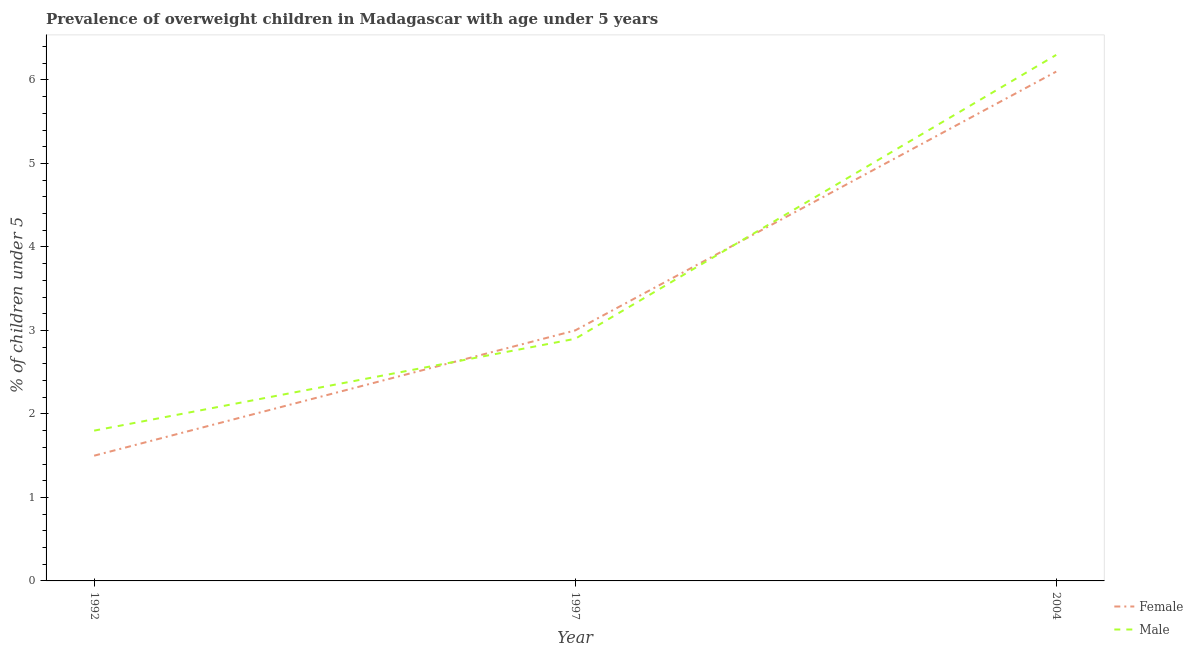How many different coloured lines are there?
Your answer should be very brief. 2. What is the percentage of obese female children in 2004?
Provide a succinct answer. 6.1. Across all years, what is the maximum percentage of obese female children?
Offer a very short reply. 6.1. In which year was the percentage of obese male children minimum?
Provide a succinct answer. 1992. What is the total percentage of obese male children in the graph?
Ensure brevity in your answer.  11. What is the difference between the percentage of obese male children in 1997 and that in 2004?
Your response must be concise. -3.4. What is the difference between the percentage of obese male children in 2004 and the percentage of obese female children in 1997?
Make the answer very short. 3.3. What is the average percentage of obese female children per year?
Your answer should be compact. 3.53. In the year 1997, what is the difference between the percentage of obese female children and percentage of obese male children?
Provide a succinct answer. 0.1. In how many years, is the percentage of obese female children greater than 6 %?
Make the answer very short. 1. What is the ratio of the percentage of obese female children in 1992 to that in 2004?
Give a very brief answer. 0.25. Is the difference between the percentage of obese female children in 1992 and 2004 greater than the difference between the percentage of obese male children in 1992 and 2004?
Keep it short and to the point. No. What is the difference between the highest and the second highest percentage of obese male children?
Offer a terse response. 3.4. What is the difference between the highest and the lowest percentage of obese female children?
Keep it short and to the point. 4.6. In how many years, is the percentage of obese male children greater than the average percentage of obese male children taken over all years?
Offer a terse response. 1. Does the percentage of obese female children monotonically increase over the years?
Make the answer very short. Yes. Is the percentage of obese female children strictly less than the percentage of obese male children over the years?
Your answer should be very brief. No. How many lines are there?
Give a very brief answer. 2. Where does the legend appear in the graph?
Offer a terse response. Bottom right. How many legend labels are there?
Ensure brevity in your answer.  2. What is the title of the graph?
Make the answer very short. Prevalence of overweight children in Madagascar with age under 5 years. Does "Electricity and heat production" appear as one of the legend labels in the graph?
Make the answer very short. No. What is the label or title of the Y-axis?
Your answer should be very brief.  % of children under 5. What is the  % of children under 5 in Male in 1992?
Keep it short and to the point. 1.8. What is the  % of children under 5 in Female in 1997?
Keep it short and to the point. 3. What is the  % of children under 5 of Male in 1997?
Give a very brief answer. 2.9. What is the  % of children under 5 in Female in 2004?
Make the answer very short. 6.1. What is the  % of children under 5 of Male in 2004?
Make the answer very short. 6.3. Across all years, what is the maximum  % of children under 5 in Female?
Your answer should be very brief. 6.1. Across all years, what is the maximum  % of children under 5 of Male?
Make the answer very short. 6.3. Across all years, what is the minimum  % of children under 5 of Female?
Make the answer very short. 1.5. Across all years, what is the minimum  % of children under 5 of Male?
Give a very brief answer. 1.8. What is the total  % of children under 5 in Female in the graph?
Offer a very short reply. 10.6. What is the difference between the  % of children under 5 in Female in 1992 and that in 1997?
Offer a very short reply. -1.5. What is the difference between the  % of children under 5 in Female in 1992 and the  % of children under 5 in Male in 1997?
Give a very brief answer. -1.4. What is the difference between the  % of children under 5 of Female in 1992 and the  % of children under 5 of Male in 2004?
Provide a succinct answer. -4.8. What is the average  % of children under 5 of Female per year?
Make the answer very short. 3.53. What is the average  % of children under 5 in Male per year?
Offer a very short reply. 3.67. In the year 1992, what is the difference between the  % of children under 5 in Female and  % of children under 5 in Male?
Your response must be concise. -0.3. In the year 1997, what is the difference between the  % of children under 5 in Female and  % of children under 5 in Male?
Ensure brevity in your answer.  0.1. What is the ratio of the  % of children under 5 of Male in 1992 to that in 1997?
Provide a short and direct response. 0.62. What is the ratio of the  % of children under 5 in Female in 1992 to that in 2004?
Make the answer very short. 0.25. What is the ratio of the  % of children under 5 in Male in 1992 to that in 2004?
Provide a succinct answer. 0.29. What is the ratio of the  % of children under 5 in Female in 1997 to that in 2004?
Provide a succinct answer. 0.49. What is the ratio of the  % of children under 5 in Male in 1997 to that in 2004?
Your answer should be compact. 0.46. What is the difference between the highest and the lowest  % of children under 5 in Female?
Keep it short and to the point. 4.6. 